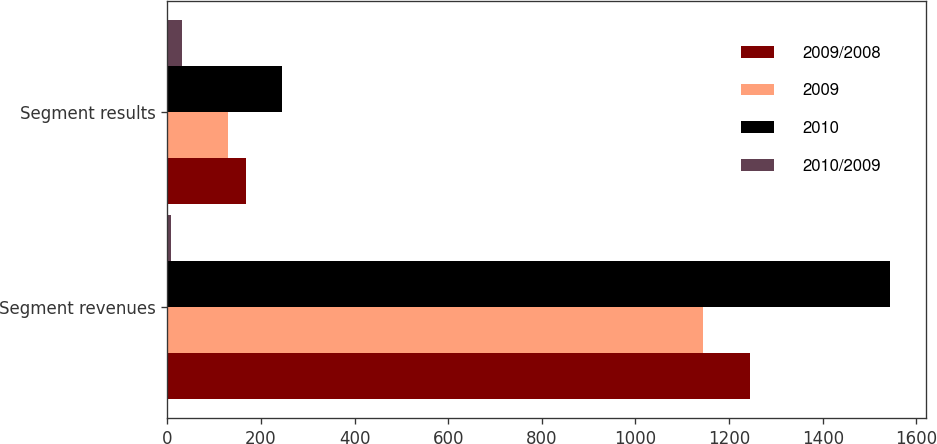<chart> <loc_0><loc_0><loc_500><loc_500><stacked_bar_chart><ecel><fcel>Segment revenues<fcel>Segment results<nl><fcel>2009/2008<fcel>1245<fcel>169<nl><fcel>2009<fcel>1145<fcel>129<nl><fcel>2010<fcel>1544<fcel>246<nl><fcel>2010/2009<fcel>9<fcel>31<nl></chart> 